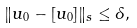Convert formula to latex. <formula><loc_0><loc_0><loc_500><loc_500>\| u _ { 0 } - [ u _ { 0 } ] \| _ { s } \leq \delta ,</formula> 